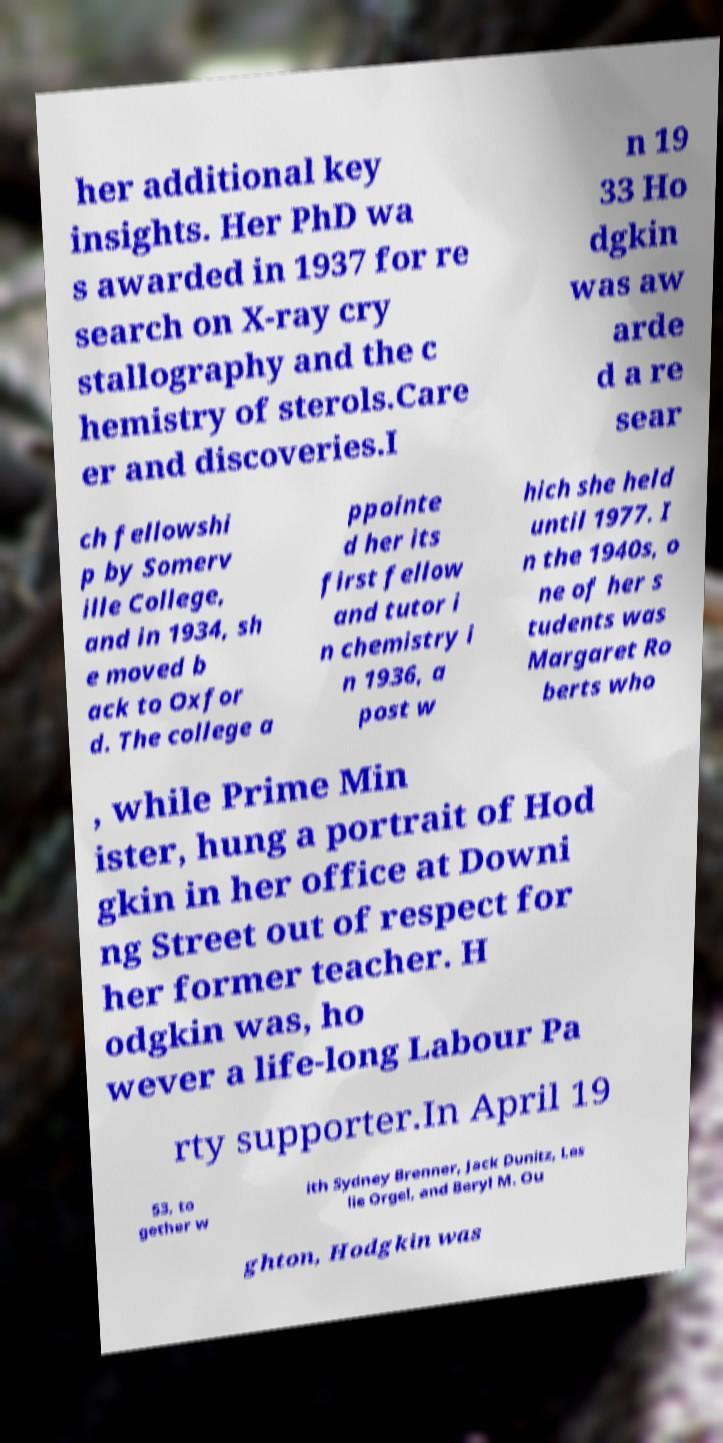Please read and relay the text visible in this image. What does it say? her additional key insights. Her PhD wa s awarded in 1937 for re search on X-ray cry stallography and the c hemistry of sterols.Care er and discoveries.I n 19 33 Ho dgkin was aw arde d a re sear ch fellowshi p by Somerv ille College, and in 1934, sh e moved b ack to Oxfor d. The college a ppointe d her its first fellow and tutor i n chemistry i n 1936, a post w hich she held until 1977. I n the 1940s, o ne of her s tudents was Margaret Ro berts who , while Prime Min ister, hung a portrait of Hod gkin in her office at Downi ng Street out of respect for her former teacher. H odgkin was, ho wever a life-long Labour Pa rty supporter.In April 19 53, to gether w ith Sydney Brenner, Jack Dunitz, Les lie Orgel, and Beryl M. Ou ghton, Hodgkin was 